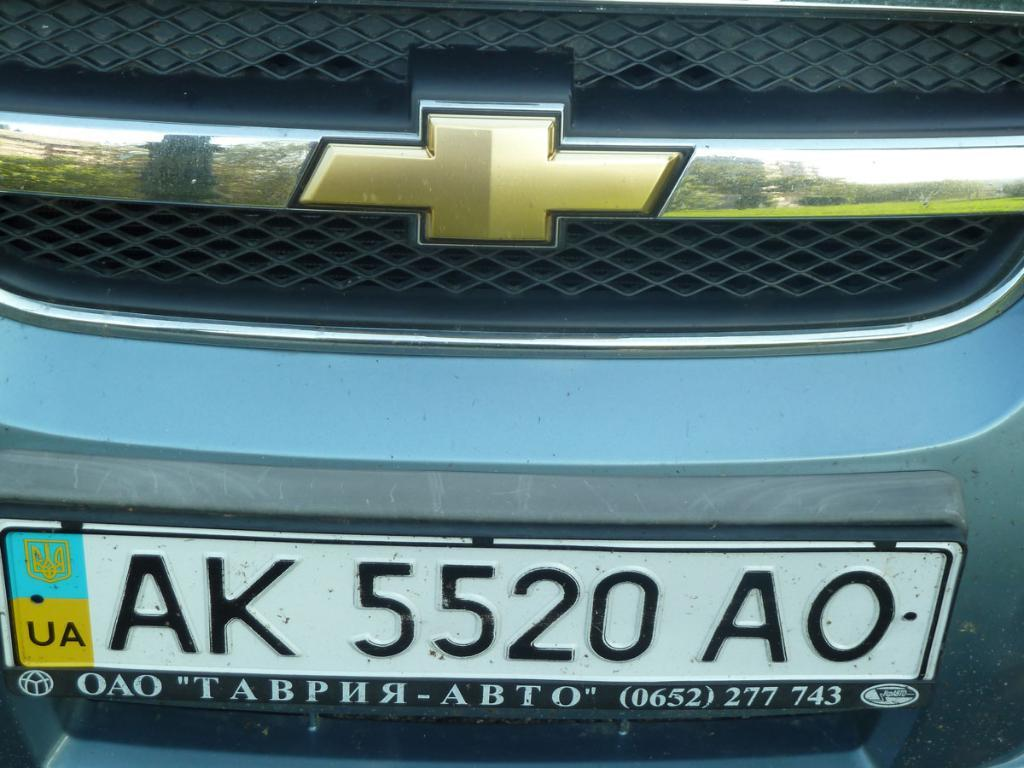<image>
Give a short and clear explanation of the subsequent image. The front grill of an automobile with license plate number AK 5520 AO. 